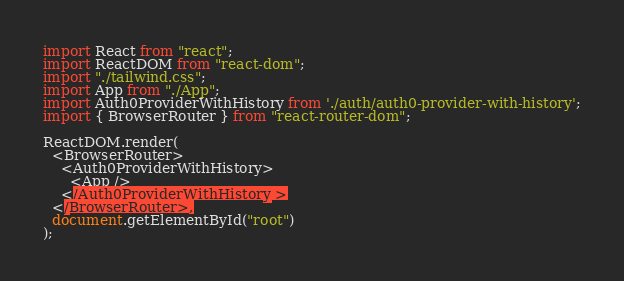Convert code to text. <code><loc_0><loc_0><loc_500><loc_500><_JavaScript_>import React from "react";
import ReactDOM from "react-dom";
import "./tailwind.css";
import App from "./App";
import Auth0ProviderWithHistory from './auth/auth0-provider-with-history';
import { BrowserRouter } from "react-router-dom";

ReactDOM.render(
  <BrowserRouter>
    <Auth0ProviderWithHistory>
      <App />
    </Auth0ProviderWithHistory >
  </BrowserRouter>,
  document.getElementById("root")
);</code> 